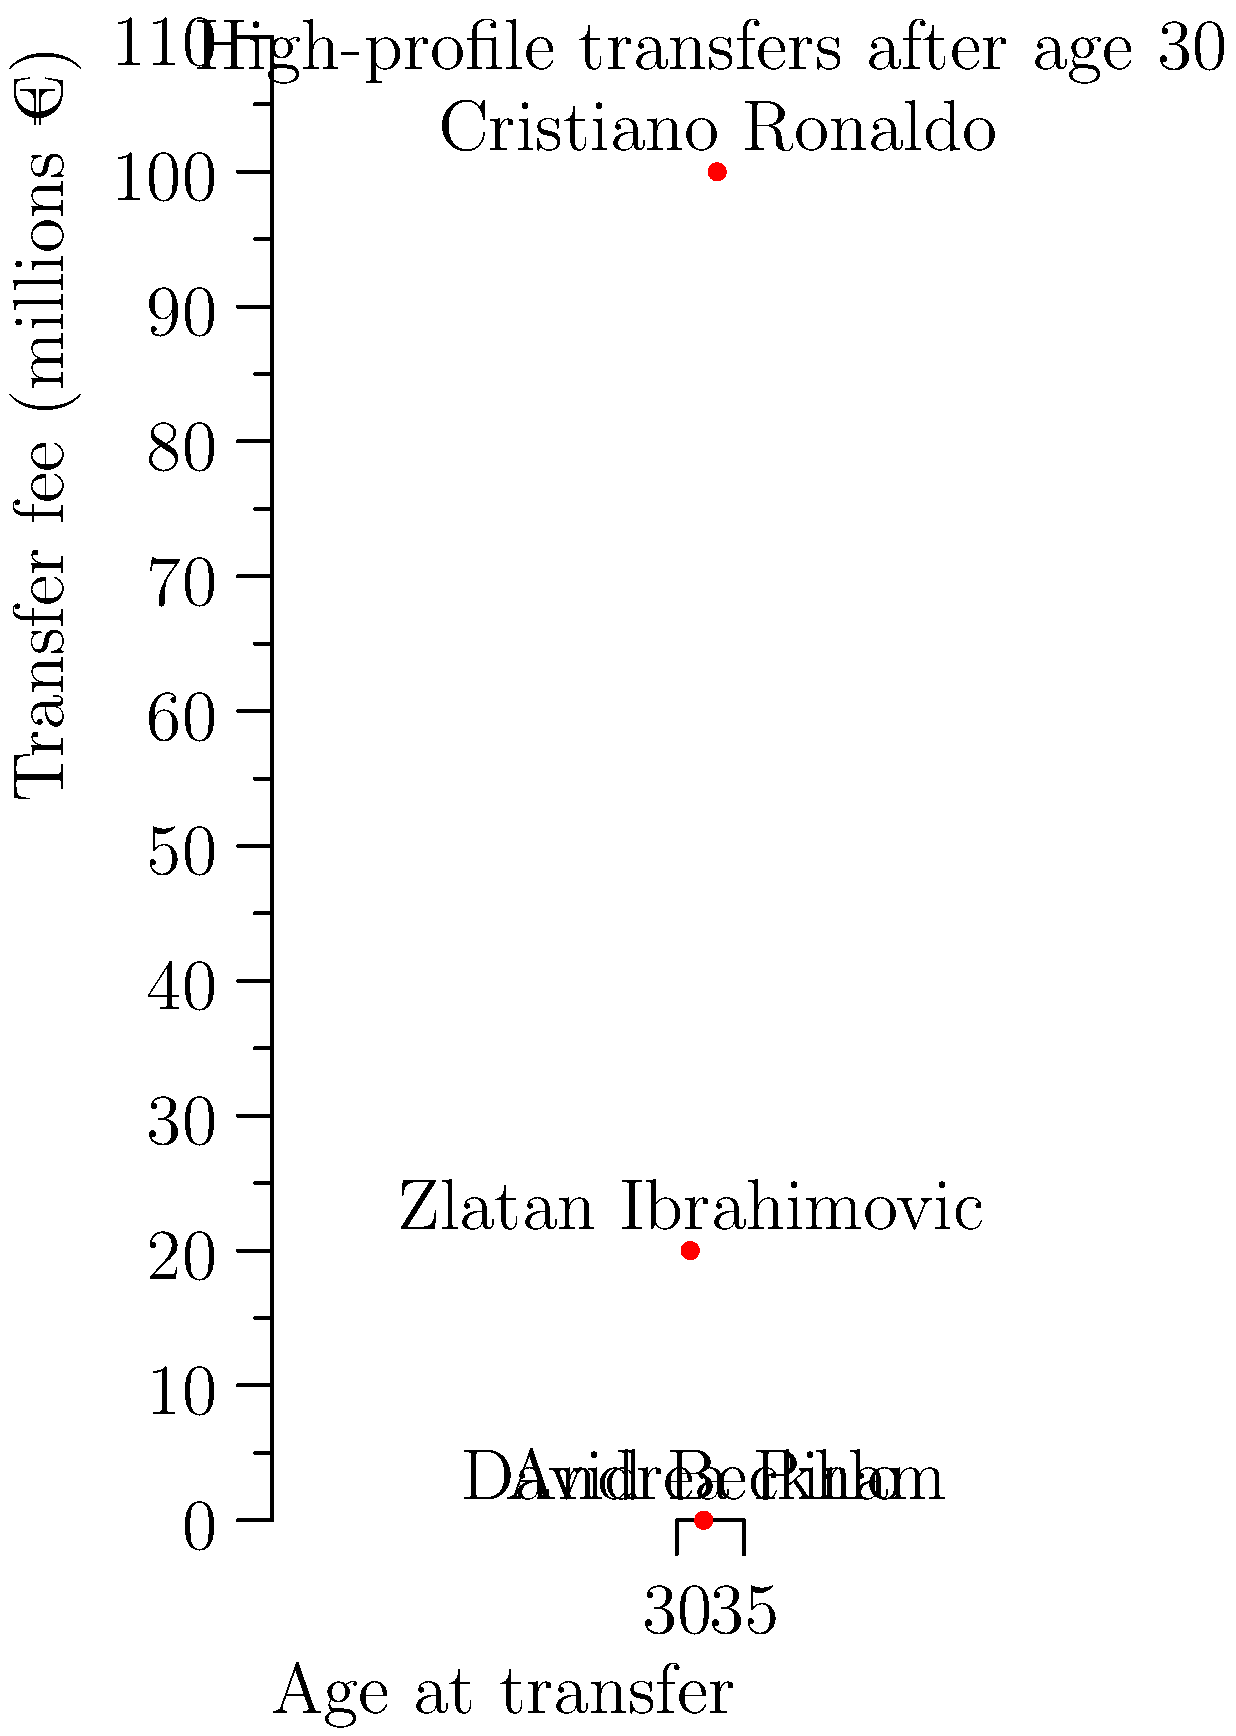Based on the infographic showing career trajectories of players who made high-profile transfers after age 30, which player's move seems to contradict the trend of declining transfer fees for older players, and what might explain this anomaly? To answer this question, let's analyze the data step-by-step:

1. The infographic shows four players who made high-profile transfers after age 30:
   - Cristiano Ronaldo: Age 33, transfer fee €100 million
   - Zlatan Ibrahimovic: Age 31, transfer fee €20 million
   - David Beckham: Age 32, transfer fee €0
   - Andrea Pirlo: Age 32, transfer fee €0

2. Generally, we expect transfer fees to decrease as players age, especially after 30, due to declining physical abilities and shorter potential contract lengths.

3. Looking at the data, we see that Beckham and Pirlo moved for free at age 32, which aligns with the expected trend for older players.

4. Ibrahimovic's transfer at 31 for €20 million is relatively high but not extraordinary for a player of his caliber at that age.

5. The anomaly in this data set is Cristiano Ronaldo's transfer at age 33 for €100 million, which is significantly higher than the other transfers and goes against the expected trend.

6. This anomaly can be explained by several factors:
   - Ronaldo's exceptional fitness and consistent high-level performance even at an advanced age
   - His global marketability and brand value, which can generate significant revenue for his new club
   - The prestige associated with signing one of the best players in football history
   - Juventus' ambition to win the Champions League, seeing Ronaldo as a key piece to achieve this goal

Therefore, Cristiano Ronaldo's transfer stands out as the anomaly in this dataset, contradicting the typical trend of declining transfer fees for older players.
Answer: Cristiano Ronaldo 